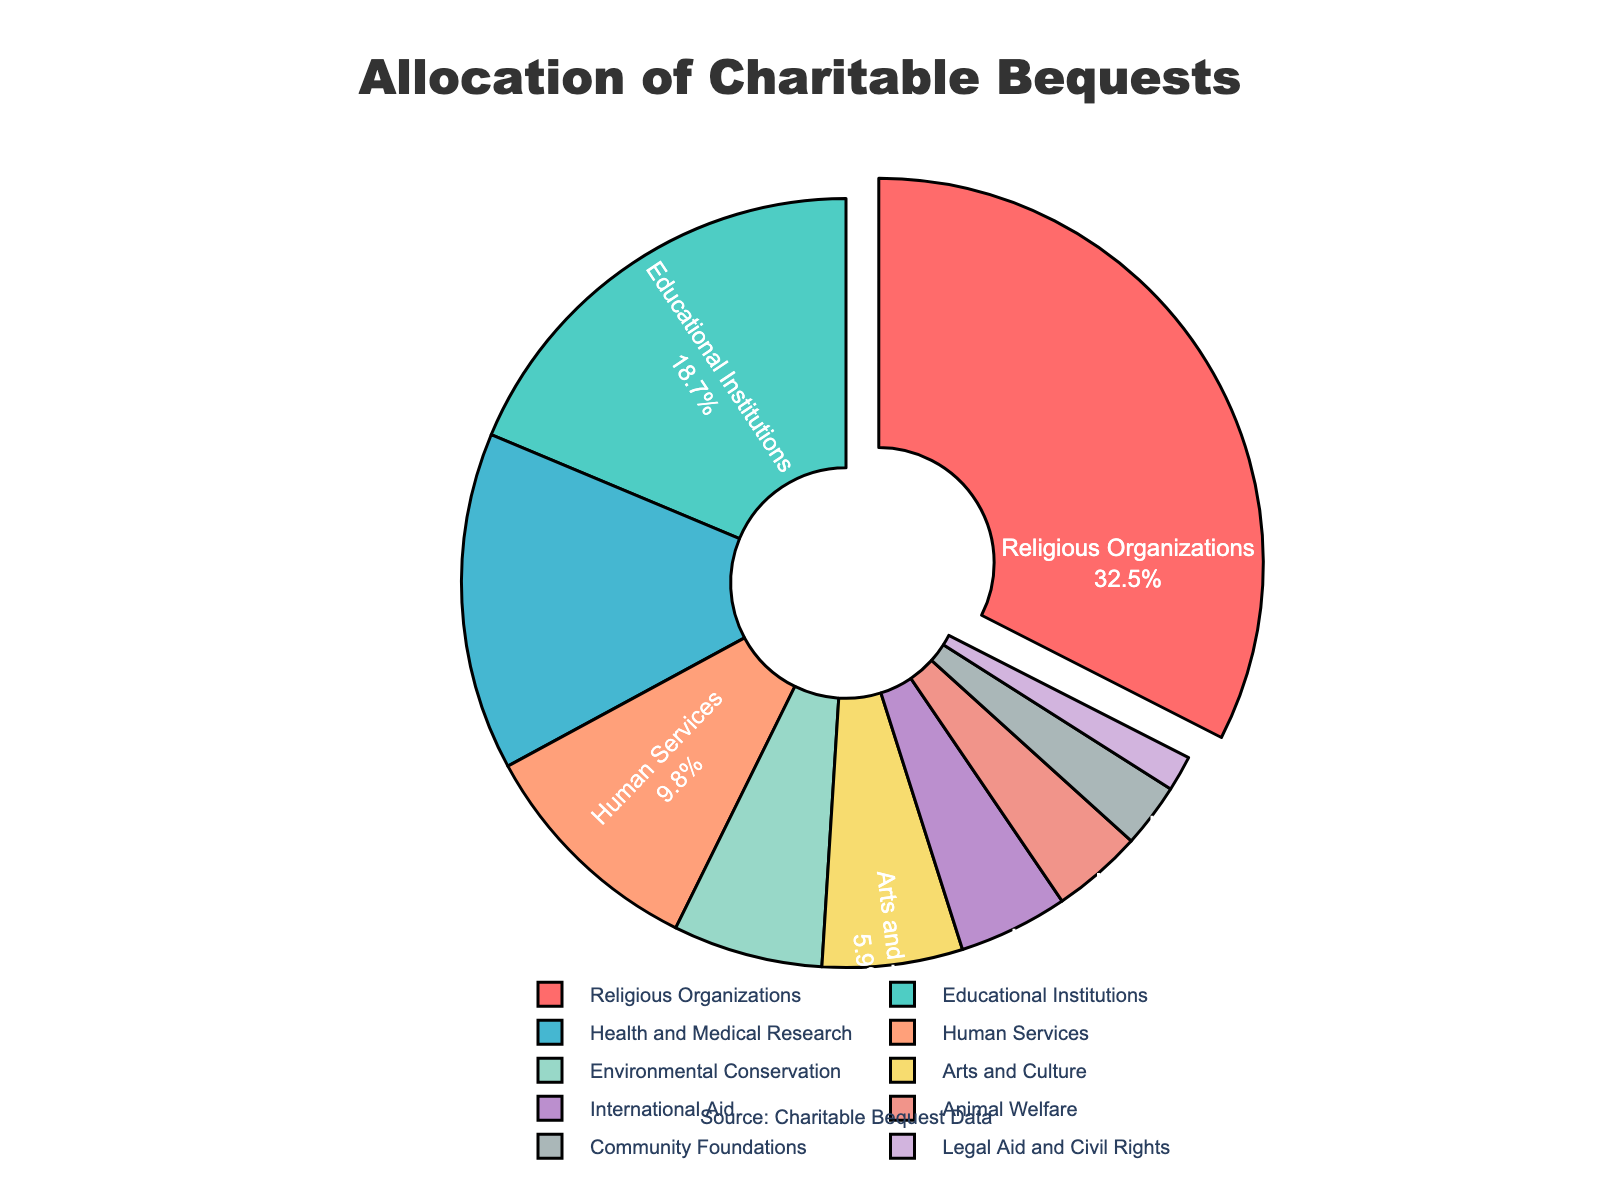which categories take up more than 10% of the pie chart? Look for and sum the percentages of the categories that are greater than 10%. The only categories that fit this criterion are Religious Organizations, Educational Institutions, and Health and Medical Research.
Answer: Religious Organizations, Educational Institutions, Health and Medical Research which category has the largest allocation in the chart? Identify the category with the highest percentage. Religious Organizations leads with 32.5%.
Answer: Religious Organizations how much more percentage do health and medical research and educational institutions together account for compared to human services? Sum the percentages of Health and Medical Research (14.2%) and Educational Institutions (18.7%), then subtract Human Services (9.8%). Calculation: 14.2 + 18.7 - 9.8 = 23.1.
Answer: 23.1 which two categories have the smallest allocations, and what is the combined percentage? Identify the two categories with the lowest percentages, which are Legal Aid and Civil Rights (1.5%) and Community Foundations (2.7%). Add these two percentages: 1.5 + 2.7 = 4.2%.
Answer: Legal Aid and Civil Rights, Community Foundations; 4.2% how does the percentage allocation for animal welfare compare to international aid? Compare the percentages directly. Animal Welfare is 3.8%, and International Aid is 4.6%. Animal Welfare is smaller.
Answer: Animal Welfare is smaller what percentage of allocations go to arts and culture, environmental conservation, and international aid combined? Add the percentages for these three categories. Calculation: 5.9 + 6.3 + 4.6 = 16.8%.
Answer: 16.8% which categories are represented by the green and red sections of the pie chart? Identify which categories these colors represent by their position in the color list. The top color categories are green for Educational Institutions and red for Religious Organizations.
Answer: Educational Institutions, Religious Organizations which two categories combined make up less than 10% of the allocation? Find two categories whose combined percentage is less than 10%. The suitable pairs are Animal Welfare (3.8%) and Community Foundations (2.7%), and Legal Aid and Civil Rights (1.5%).
Answer: Animal Welfare, Community Foundations; Legal Aid and Civil Rights 